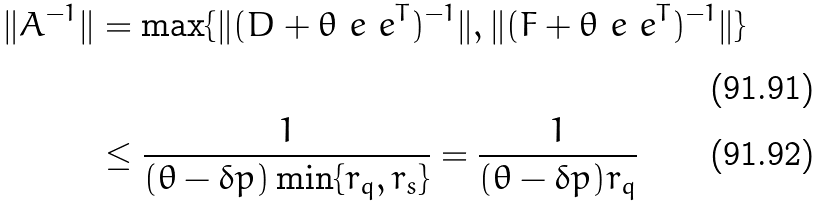<formula> <loc_0><loc_0><loc_500><loc_500>\| A ^ { - 1 } \| & = \max \{ \| ( D + \theta \ e \ e ^ { T } ) ^ { - 1 } \| , \| ( F + \theta \ e \ e ^ { T } ) ^ { - 1 } \| \} \\ & \leq \frac { 1 } { ( \theta - \delta p ) \min \{ r _ { q } , r _ { s } \} } = \frac { 1 } { ( \theta - \delta p ) r _ { q } }</formula> 